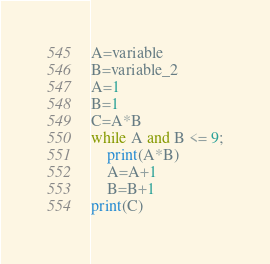Convert code to text. <code><loc_0><loc_0><loc_500><loc_500><_Python_>A=variable
B=variable_2
A=1
B=1
C=A*B
while A and B <= 9;
	print(A*B)
	A=A+1
	B=B+1
print(C)</code> 